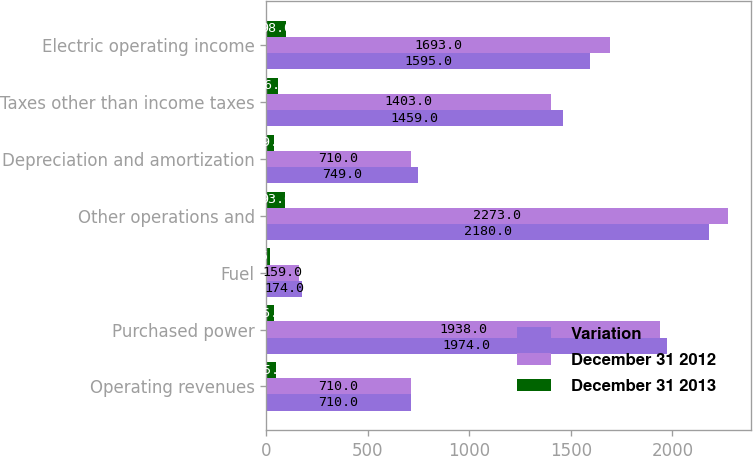Convert chart to OTSL. <chart><loc_0><loc_0><loc_500><loc_500><stacked_bar_chart><ecel><fcel>Operating revenues<fcel>Purchased power<fcel>Fuel<fcel>Other operations and<fcel>Depreciation and amortization<fcel>Taxes other than income taxes<fcel>Electric operating income<nl><fcel>Variation<fcel>710<fcel>1974<fcel>174<fcel>2180<fcel>749<fcel>1459<fcel>1595<nl><fcel>December 31 2012<fcel>710<fcel>1938<fcel>159<fcel>2273<fcel>710<fcel>1403<fcel>1693<nl><fcel>December 31 2013<fcel>45<fcel>36<fcel>15<fcel>93<fcel>39<fcel>56<fcel>98<nl></chart> 